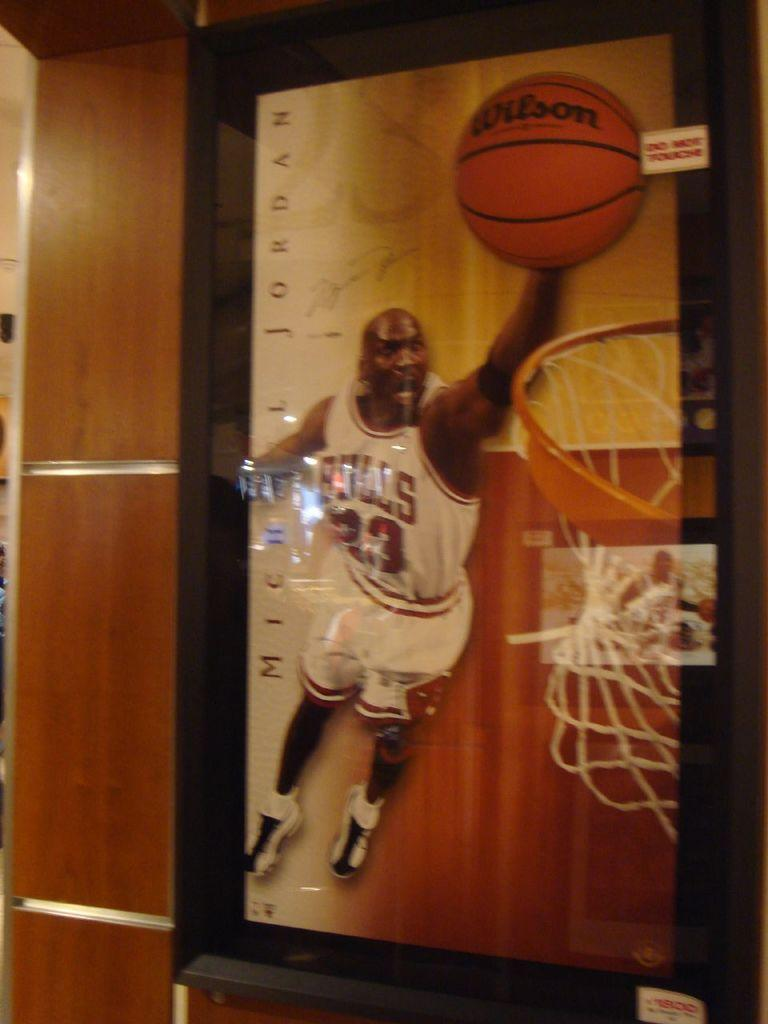<image>
Present a compact description of the photo's key features. A picture of a man with a basketball states that he is Michael Jordan. 